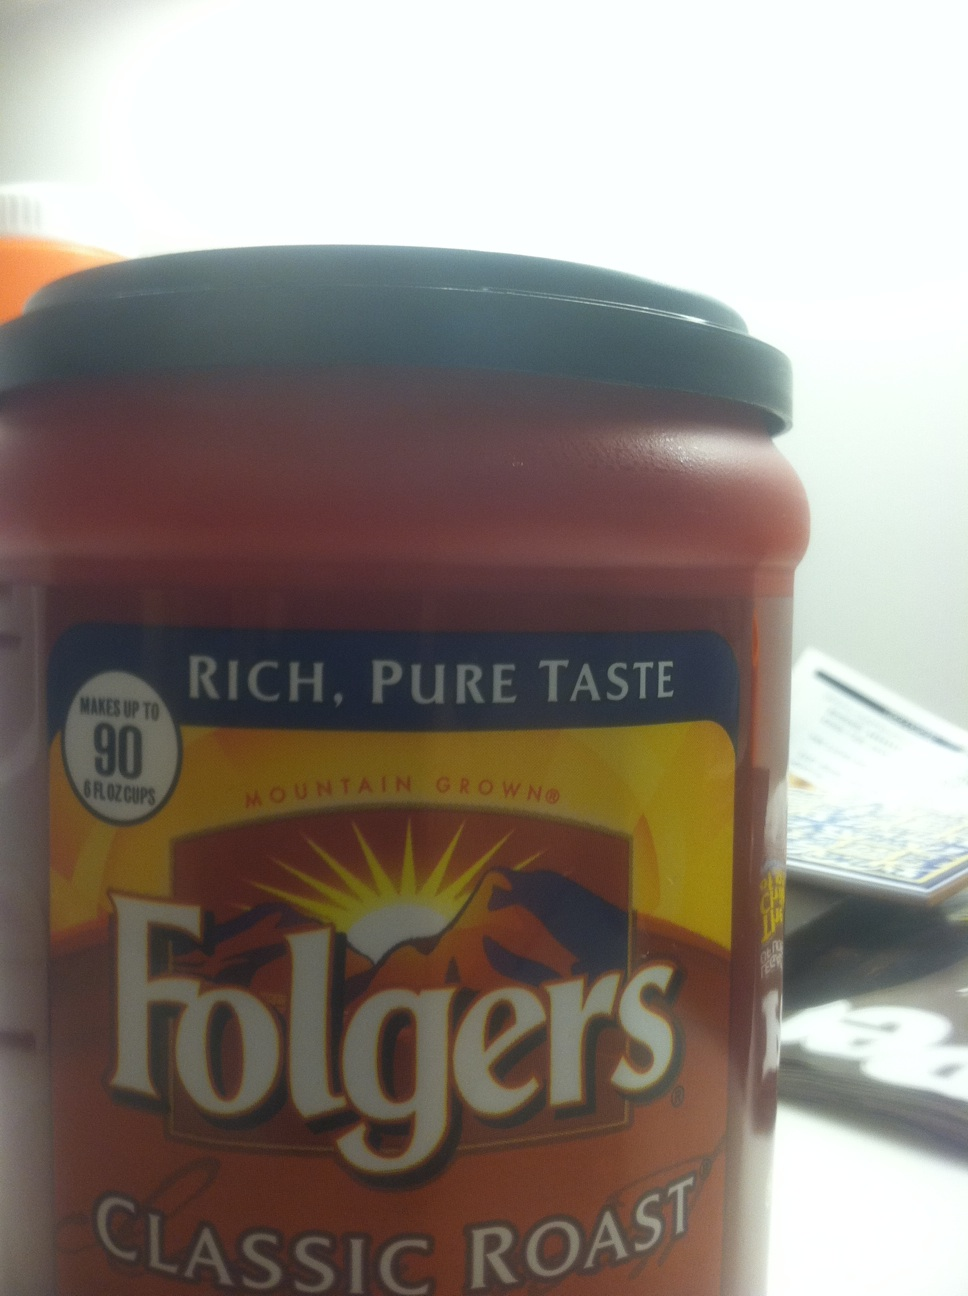What kind of coffee is this? The coffee shown in the image is Folgers Classic Roast, which is a popular brand of ground coffee known for its rich, pure taste and is often marketed as the classic medium roast to start your day with. 